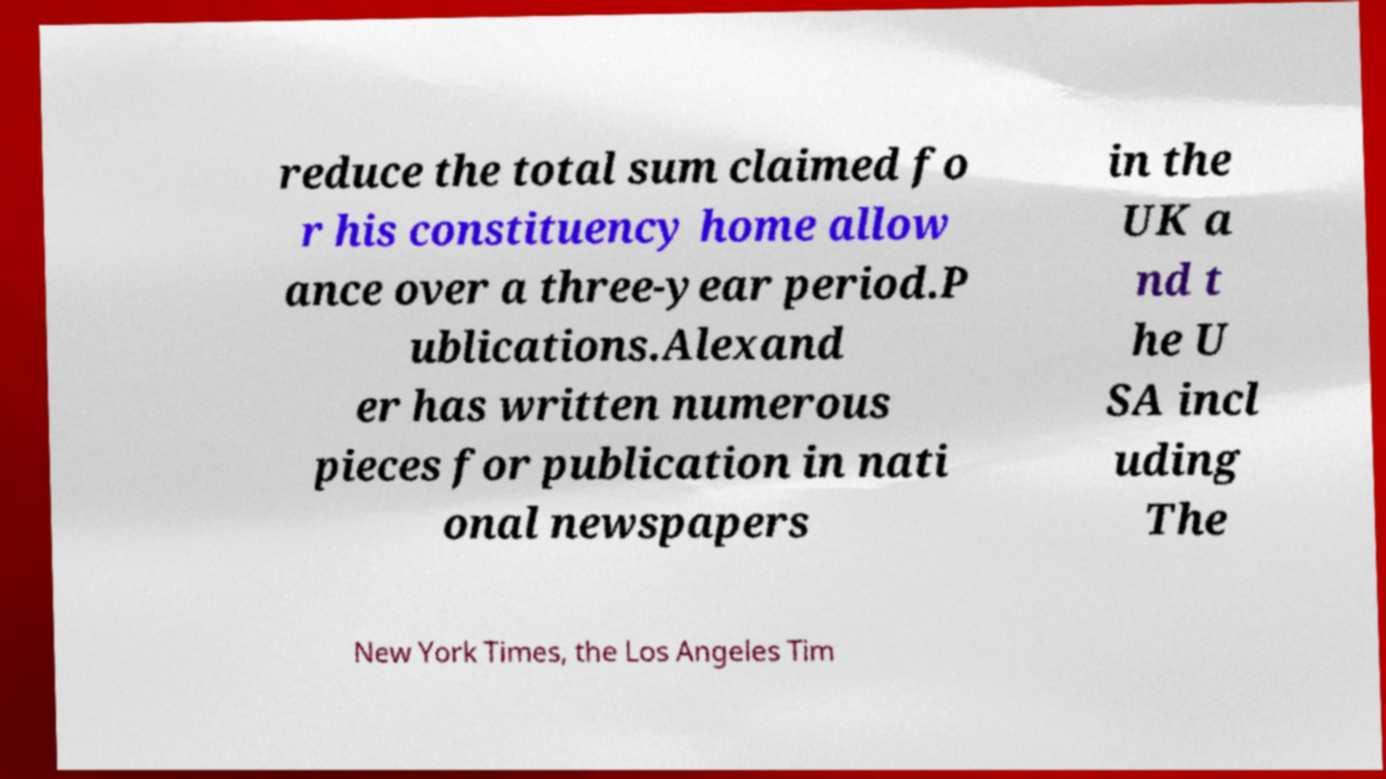Please read and relay the text visible in this image. What does it say? reduce the total sum claimed fo r his constituency home allow ance over a three-year period.P ublications.Alexand er has written numerous pieces for publication in nati onal newspapers in the UK a nd t he U SA incl uding The New York Times, the Los Angeles Tim 